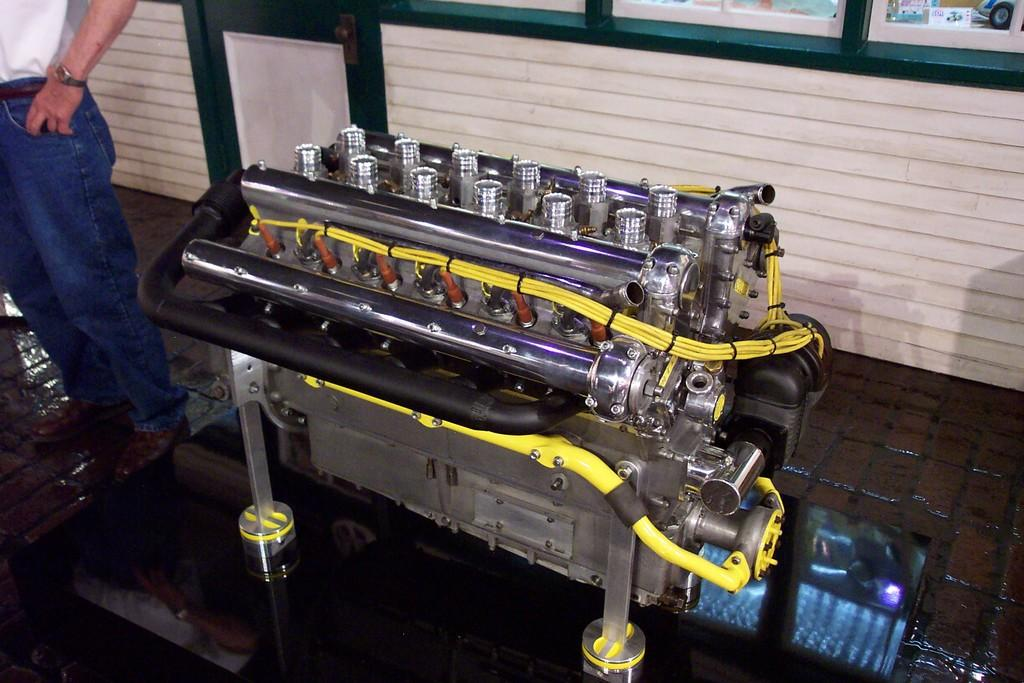What can be seen in the image besides the person? There is an equipment in the image. What is the person wearing in the image? The person is wearing a white dress, blue jeans, and brown shoes. What accessory is the person wearing in the image? The person is wearing a watch. What type of pie is being served by the person in the image? There is no pie present in the image; the person is not serving any food. 